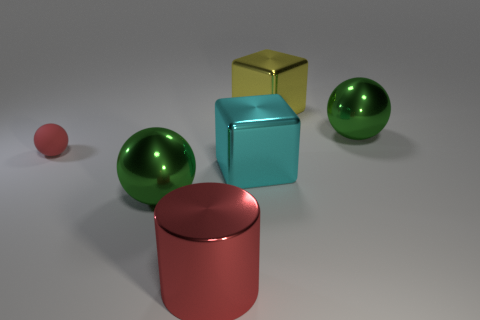Is there any other thing that is the same shape as the large red metal object?
Offer a very short reply. No. There is a metal object that is in front of the cyan shiny block and behind the big red metal thing; what shape is it?
Your response must be concise. Sphere. Is there any other thing that is the same size as the rubber thing?
Your answer should be very brief. No. What is the color of the sphere to the right of the block that is in front of the matte thing?
Offer a terse response. Green. There is a big green object behind the large shiny block that is in front of the ball to the right of the big cylinder; what shape is it?
Keep it short and to the point. Sphere. What is the size of the shiny thing that is behind the large cyan metallic thing and in front of the yellow thing?
Keep it short and to the point. Large. How many big cylinders are the same color as the tiny thing?
Provide a succinct answer. 1. What is the material of the large cylinder that is the same color as the small sphere?
Your answer should be compact. Metal. What material is the small red sphere?
Keep it short and to the point. Rubber. Does the cylinder left of the yellow block have the same material as the big cyan block?
Ensure brevity in your answer.  Yes. 